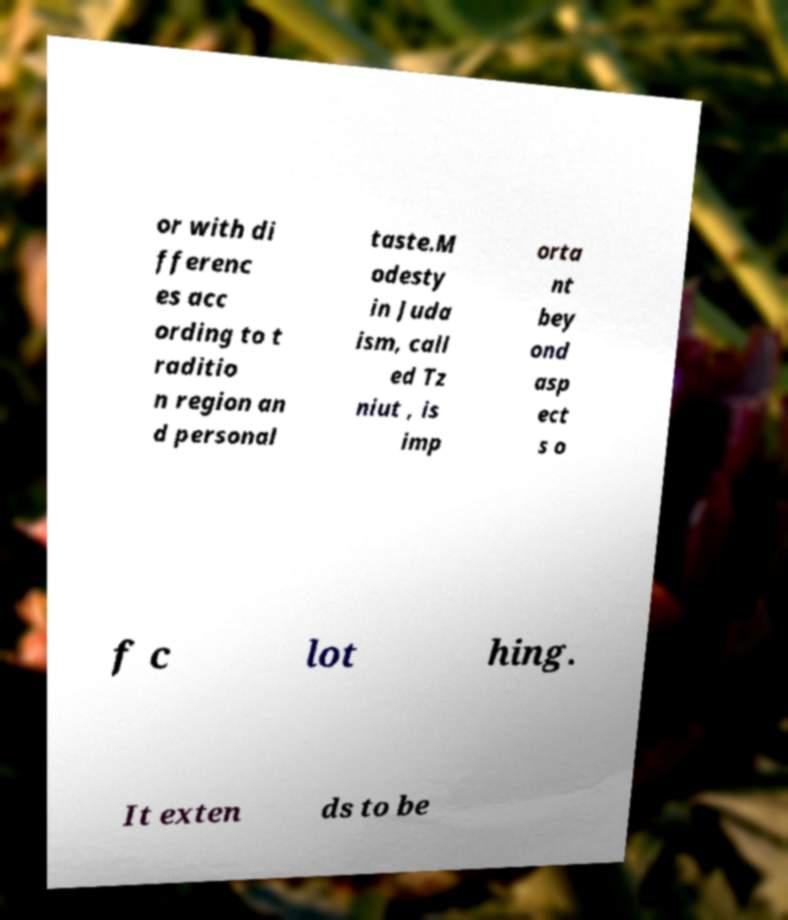Please identify and transcribe the text found in this image. or with di fferenc es acc ording to t raditio n region an d personal taste.M odesty in Juda ism, call ed Tz niut , is imp orta nt bey ond asp ect s o f c lot hing. It exten ds to be 